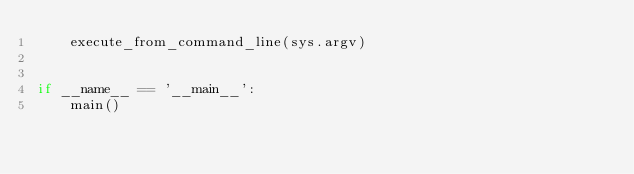<code> <loc_0><loc_0><loc_500><loc_500><_Python_>    execute_from_command_line(sys.argv)


if __name__ == '__main__':
    main()
</code> 